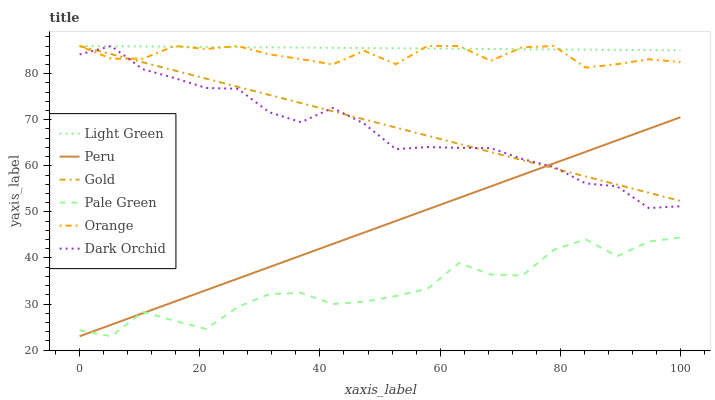Does Pale Green have the minimum area under the curve?
Answer yes or no. Yes. Does Light Green have the maximum area under the curve?
Answer yes or no. Yes. Does Gold have the minimum area under the curve?
Answer yes or no. No. Does Gold have the maximum area under the curve?
Answer yes or no. No. Is Peru the smoothest?
Answer yes or no. Yes. Is Pale Green the roughest?
Answer yes or no. Yes. Is Gold the smoothest?
Answer yes or no. No. Is Gold the roughest?
Answer yes or no. No. Does Pale Green have the lowest value?
Answer yes or no. Yes. Does Gold have the lowest value?
Answer yes or no. No. Does Orange have the highest value?
Answer yes or no. Yes. Does Pale Green have the highest value?
Answer yes or no. No. Is Peru less than Light Green?
Answer yes or no. Yes. Is Dark Orchid greater than Pale Green?
Answer yes or no. Yes. Does Gold intersect Dark Orchid?
Answer yes or no. Yes. Is Gold less than Dark Orchid?
Answer yes or no. No. Is Gold greater than Dark Orchid?
Answer yes or no. No. Does Peru intersect Light Green?
Answer yes or no. No. 